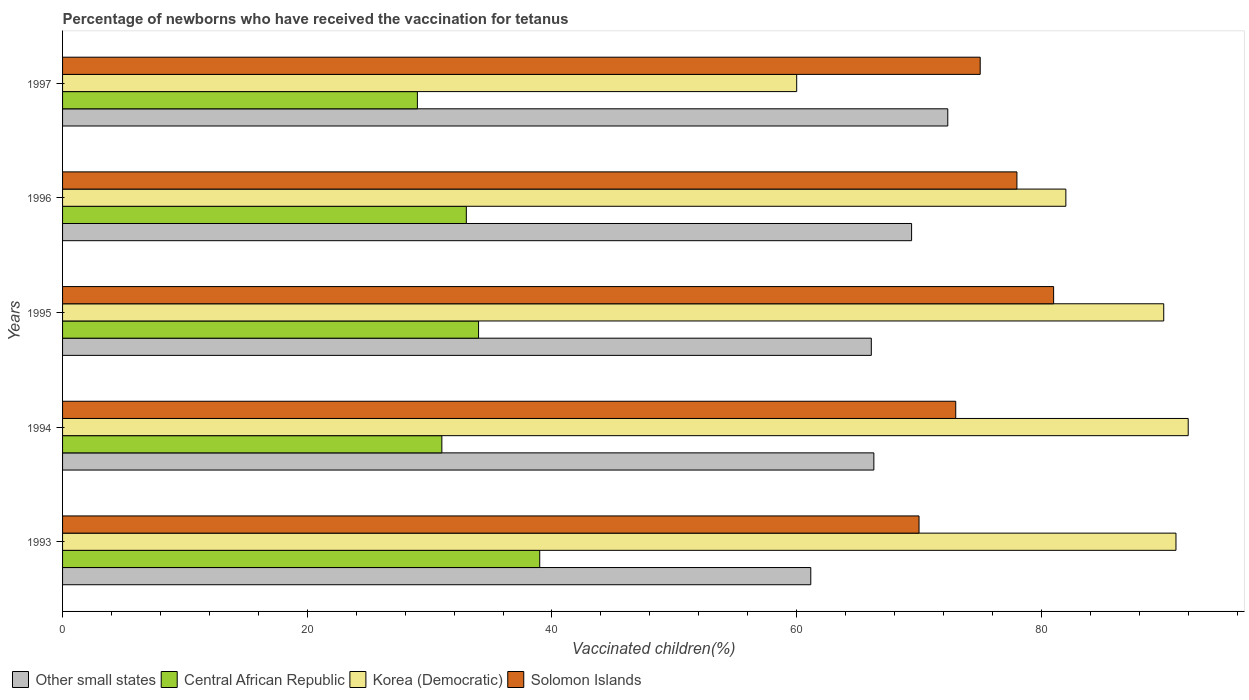How many groups of bars are there?
Make the answer very short. 5. Are the number of bars per tick equal to the number of legend labels?
Your response must be concise. Yes. Are the number of bars on each tick of the Y-axis equal?
Provide a short and direct response. Yes. In how many cases, is the number of bars for a given year not equal to the number of legend labels?
Ensure brevity in your answer.  0. What is the percentage of vaccinated children in Other small states in 1993?
Your answer should be compact. 61.15. Across all years, what is the maximum percentage of vaccinated children in Korea (Democratic)?
Offer a terse response. 92. Across all years, what is the minimum percentage of vaccinated children in Other small states?
Provide a short and direct response. 61.15. In which year was the percentage of vaccinated children in Korea (Democratic) minimum?
Make the answer very short. 1997. What is the total percentage of vaccinated children in Solomon Islands in the graph?
Make the answer very short. 377. What is the difference between the percentage of vaccinated children in Other small states in 1994 and that in 1997?
Your answer should be compact. -6.04. What is the difference between the percentage of vaccinated children in Other small states in 1993 and the percentage of vaccinated children in Central African Republic in 1997?
Ensure brevity in your answer.  32.15. What is the average percentage of vaccinated children in Solomon Islands per year?
Offer a very short reply. 75.4. What is the ratio of the percentage of vaccinated children in Other small states in 1994 to that in 1995?
Give a very brief answer. 1. Is the difference between the percentage of vaccinated children in Korea (Democratic) in 1995 and 1996 greater than the difference between the percentage of vaccinated children in Solomon Islands in 1995 and 1996?
Give a very brief answer. Yes. What is the difference between the highest and the lowest percentage of vaccinated children in Solomon Islands?
Your response must be concise. 11. Is the sum of the percentage of vaccinated children in Korea (Democratic) in 1994 and 1996 greater than the maximum percentage of vaccinated children in Other small states across all years?
Keep it short and to the point. Yes. What does the 2nd bar from the top in 1993 represents?
Ensure brevity in your answer.  Korea (Democratic). What does the 3rd bar from the bottom in 1996 represents?
Your answer should be very brief. Korea (Democratic). Is it the case that in every year, the sum of the percentage of vaccinated children in Central African Republic and percentage of vaccinated children in Other small states is greater than the percentage of vaccinated children in Korea (Democratic)?
Give a very brief answer. Yes. How many bars are there?
Offer a very short reply. 20. Are all the bars in the graph horizontal?
Give a very brief answer. Yes. What is the difference between two consecutive major ticks on the X-axis?
Your response must be concise. 20. Does the graph contain any zero values?
Offer a very short reply. No. Where does the legend appear in the graph?
Provide a succinct answer. Bottom left. How many legend labels are there?
Keep it short and to the point. 4. What is the title of the graph?
Provide a succinct answer. Percentage of newborns who have received the vaccination for tetanus. Does "Antigua and Barbuda" appear as one of the legend labels in the graph?
Offer a very short reply. No. What is the label or title of the X-axis?
Offer a terse response. Vaccinated children(%). What is the Vaccinated children(%) in Other small states in 1993?
Provide a succinct answer. 61.15. What is the Vaccinated children(%) in Korea (Democratic) in 1993?
Offer a very short reply. 91. What is the Vaccinated children(%) of Other small states in 1994?
Keep it short and to the point. 66.31. What is the Vaccinated children(%) of Central African Republic in 1994?
Make the answer very short. 31. What is the Vaccinated children(%) in Korea (Democratic) in 1994?
Offer a very short reply. 92. What is the Vaccinated children(%) in Solomon Islands in 1994?
Provide a succinct answer. 73. What is the Vaccinated children(%) of Other small states in 1995?
Make the answer very short. 66.1. What is the Vaccinated children(%) in Korea (Democratic) in 1995?
Give a very brief answer. 90. What is the Vaccinated children(%) of Other small states in 1996?
Make the answer very short. 69.39. What is the Vaccinated children(%) in Central African Republic in 1996?
Offer a very short reply. 33. What is the Vaccinated children(%) in Other small states in 1997?
Your answer should be compact. 72.35. What is the Vaccinated children(%) in Central African Republic in 1997?
Provide a succinct answer. 29. Across all years, what is the maximum Vaccinated children(%) of Other small states?
Your answer should be very brief. 72.35. Across all years, what is the maximum Vaccinated children(%) in Central African Republic?
Offer a terse response. 39. Across all years, what is the maximum Vaccinated children(%) of Korea (Democratic)?
Keep it short and to the point. 92. Across all years, what is the minimum Vaccinated children(%) of Other small states?
Your answer should be very brief. 61.15. Across all years, what is the minimum Vaccinated children(%) of Solomon Islands?
Ensure brevity in your answer.  70. What is the total Vaccinated children(%) of Other small states in the graph?
Your response must be concise. 335.3. What is the total Vaccinated children(%) in Central African Republic in the graph?
Offer a very short reply. 166. What is the total Vaccinated children(%) of Korea (Democratic) in the graph?
Ensure brevity in your answer.  415. What is the total Vaccinated children(%) of Solomon Islands in the graph?
Keep it short and to the point. 377. What is the difference between the Vaccinated children(%) of Other small states in 1993 and that in 1994?
Your answer should be compact. -5.16. What is the difference between the Vaccinated children(%) in Central African Republic in 1993 and that in 1994?
Your response must be concise. 8. What is the difference between the Vaccinated children(%) in Solomon Islands in 1993 and that in 1994?
Keep it short and to the point. -3. What is the difference between the Vaccinated children(%) of Other small states in 1993 and that in 1995?
Provide a succinct answer. -4.95. What is the difference between the Vaccinated children(%) of Central African Republic in 1993 and that in 1995?
Provide a succinct answer. 5. What is the difference between the Vaccinated children(%) of Korea (Democratic) in 1993 and that in 1995?
Keep it short and to the point. 1. What is the difference between the Vaccinated children(%) in Other small states in 1993 and that in 1996?
Your answer should be compact. -8.24. What is the difference between the Vaccinated children(%) in Other small states in 1993 and that in 1997?
Provide a short and direct response. -11.2. What is the difference between the Vaccinated children(%) of Central African Republic in 1993 and that in 1997?
Offer a very short reply. 10. What is the difference between the Vaccinated children(%) of Korea (Democratic) in 1993 and that in 1997?
Offer a very short reply. 31. What is the difference between the Vaccinated children(%) in Solomon Islands in 1993 and that in 1997?
Provide a succinct answer. -5. What is the difference between the Vaccinated children(%) of Other small states in 1994 and that in 1995?
Provide a succinct answer. 0.21. What is the difference between the Vaccinated children(%) of Central African Republic in 1994 and that in 1995?
Provide a short and direct response. -3. What is the difference between the Vaccinated children(%) of Korea (Democratic) in 1994 and that in 1995?
Your answer should be very brief. 2. What is the difference between the Vaccinated children(%) of Other small states in 1994 and that in 1996?
Offer a very short reply. -3.08. What is the difference between the Vaccinated children(%) in Central African Republic in 1994 and that in 1996?
Offer a terse response. -2. What is the difference between the Vaccinated children(%) in Korea (Democratic) in 1994 and that in 1996?
Offer a very short reply. 10. What is the difference between the Vaccinated children(%) in Other small states in 1994 and that in 1997?
Your answer should be very brief. -6.04. What is the difference between the Vaccinated children(%) of Korea (Democratic) in 1994 and that in 1997?
Make the answer very short. 32. What is the difference between the Vaccinated children(%) in Other small states in 1995 and that in 1996?
Provide a succinct answer. -3.29. What is the difference between the Vaccinated children(%) of Central African Republic in 1995 and that in 1996?
Give a very brief answer. 1. What is the difference between the Vaccinated children(%) in Korea (Democratic) in 1995 and that in 1996?
Provide a short and direct response. 8. What is the difference between the Vaccinated children(%) in Solomon Islands in 1995 and that in 1996?
Provide a succinct answer. 3. What is the difference between the Vaccinated children(%) in Other small states in 1995 and that in 1997?
Your answer should be compact. -6.25. What is the difference between the Vaccinated children(%) in Central African Republic in 1995 and that in 1997?
Keep it short and to the point. 5. What is the difference between the Vaccinated children(%) in Korea (Democratic) in 1995 and that in 1997?
Your answer should be compact. 30. What is the difference between the Vaccinated children(%) in Other small states in 1996 and that in 1997?
Make the answer very short. -2.96. What is the difference between the Vaccinated children(%) in Central African Republic in 1996 and that in 1997?
Give a very brief answer. 4. What is the difference between the Vaccinated children(%) of Other small states in 1993 and the Vaccinated children(%) of Central African Republic in 1994?
Offer a terse response. 30.15. What is the difference between the Vaccinated children(%) of Other small states in 1993 and the Vaccinated children(%) of Korea (Democratic) in 1994?
Your answer should be very brief. -30.85. What is the difference between the Vaccinated children(%) of Other small states in 1993 and the Vaccinated children(%) of Solomon Islands in 1994?
Make the answer very short. -11.85. What is the difference between the Vaccinated children(%) in Central African Republic in 1993 and the Vaccinated children(%) in Korea (Democratic) in 1994?
Your answer should be compact. -53. What is the difference between the Vaccinated children(%) of Central African Republic in 1993 and the Vaccinated children(%) of Solomon Islands in 1994?
Provide a succinct answer. -34. What is the difference between the Vaccinated children(%) of Korea (Democratic) in 1993 and the Vaccinated children(%) of Solomon Islands in 1994?
Give a very brief answer. 18. What is the difference between the Vaccinated children(%) in Other small states in 1993 and the Vaccinated children(%) in Central African Republic in 1995?
Your answer should be compact. 27.15. What is the difference between the Vaccinated children(%) of Other small states in 1993 and the Vaccinated children(%) of Korea (Democratic) in 1995?
Your answer should be very brief. -28.85. What is the difference between the Vaccinated children(%) of Other small states in 1993 and the Vaccinated children(%) of Solomon Islands in 1995?
Offer a very short reply. -19.85. What is the difference between the Vaccinated children(%) in Central African Republic in 1993 and the Vaccinated children(%) in Korea (Democratic) in 1995?
Provide a short and direct response. -51. What is the difference between the Vaccinated children(%) of Central African Republic in 1993 and the Vaccinated children(%) of Solomon Islands in 1995?
Your answer should be very brief. -42. What is the difference between the Vaccinated children(%) of Other small states in 1993 and the Vaccinated children(%) of Central African Republic in 1996?
Offer a terse response. 28.15. What is the difference between the Vaccinated children(%) of Other small states in 1993 and the Vaccinated children(%) of Korea (Democratic) in 1996?
Provide a succinct answer. -20.85. What is the difference between the Vaccinated children(%) of Other small states in 1993 and the Vaccinated children(%) of Solomon Islands in 1996?
Your answer should be compact. -16.85. What is the difference between the Vaccinated children(%) in Central African Republic in 1993 and the Vaccinated children(%) in Korea (Democratic) in 1996?
Offer a terse response. -43. What is the difference between the Vaccinated children(%) in Central African Republic in 1993 and the Vaccinated children(%) in Solomon Islands in 1996?
Your answer should be compact. -39. What is the difference between the Vaccinated children(%) of Korea (Democratic) in 1993 and the Vaccinated children(%) of Solomon Islands in 1996?
Offer a very short reply. 13. What is the difference between the Vaccinated children(%) in Other small states in 1993 and the Vaccinated children(%) in Central African Republic in 1997?
Your answer should be compact. 32.15. What is the difference between the Vaccinated children(%) in Other small states in 1993 and the Vaccinated children(%) in Korea (Democratic) in 1997?
Your answer should be very brief. 1.15. What is the difference between the Vaccinated children(%) of Other small states in 1993 and the Vaccinated children(%) of Solomon Islands in 1997?
Your response must be concise. -13.85. What is the difference between the Vaccinated children(%) in Central African Republic in 1993 and the Vaccinated children(%) in Solomon Islands in 1997?
Provide a short and direct response. -36. What is the difference between the Vaccinated children(%) of Korea (Democratic) in 1993 and the Vaccinated children(%) of Solomon Islands in 1997?
Offer a terse response. 16. What is the difference between the Vaccinated children(%) in Other small states in 1994 and the Vaccinated children(%) in Central African Republic in 1995?
Ensure brevity in your answer.  32.31. What is the difference between the Vaccinated children(%) in Other small states in 1994 and the Vaccinated children(%) in Korea (Democratic) in 1995?
Make the answer very short. -23.69. What is the difference between the Vaccinated children(%) in Other small states in 1994 and the Vaccinated children(%) in Solomon Islands in 1995?
Your answer should be very brief. -14.69. What is the difference between the Vaccinated children(%) in Central African Republic in 1994 and the Vaccinated children(%) in Korea (Democratic) in 1995?
Keep it short and to the point. -59. What is the difference between the Vaccinated children(%) of Central African Republic in 1994 and the Vaccinated children(%) of Solomon Islands in 1995?
Give a very brief answer. -50. What is the difference between the Vaccinated children(%) of Other small states in 1994 and the Vaccinated children(%) of Central African Republic in 1996?
Your response must be concise. 33.31. What is the difference between the Vaccinated children(%) of Other small states in 1994 and the Vaccinated children(%) of Korea (Democratic) in 1996?
Your answer should be very brief. -15.69. What is the difference between the Vaccinated children(%) of Other small states in 1994 and the Vaccinated children(%) of Solomon Islands in 1996?
Your response must be concise. -11.69. What is the difference between the Vaccinated children(%) of Central African Republic in 1994 and the Vaccinated children(%) of Korea (Democratic) in 1996?
Offer a very short reply. -51. What is the difference between the Vaccinated children(%) of Central African Republic in 1994 and the Vaccinated children(%) of Solomon Islands in 1996?
Offer a very short reply. -47. What is the difference between the Vaccinated children(%) in Other small states in 1994 and the Vaccinated children(%) in Central African Republic in 1997?
Provide a short and direct response. 37.31. What is the difference between the Vaccinated children(%) in Other small states in 1994 and the Vaccinated children(%) in Korea (Democratic) in 1997?
Make the answer very short. 6.31. What is the difference between the Vaccinated children(%) of Other small states in 1994 and the Vaccinated children(%) of Solomon Islands in 1997?
Provide a succinct answer. -8.69. What is the difference between the Vaccinated children(%) of Central African Republic in 1994 and the Vaccinated children(%) of Solomon Islands in 1997?
Give a very brief answer. -44. What is the difference between the Vaccinated children(%) in Korea (Democratic) in 1994 and the Vaccinated children(%) in Solomon Islands in 1997?
Make the answer very short. 17. What is the difference between the Vaccinated children(%) of Other small states in 1995 and the Vaccinated children(%) of Central African Republic in 1996?
Provide a succinct answer. 33.1. What is the difference between the Vaccinated children(%) in Other small states in 1995 and the Vaccinated children(%) in Korea (Democratic) in 1996?
Your response must be concise. -15.9. What is the difference between the Vaccinated children(%) of Other small states in 1995 and the Vaccinated children(%) of Solomon Islands in 1996?
Give a very brief answer. -11.9. What is the difference between the Vaccinated children(%) in Central African Republic in 1995 and the Vaccinated children(%) in Korea (Democratic) in 1996?
Ensure brevity in your answer.  -48. What is the difference between the Vaccinated children(%) in Central African Republic in 1995 and the Vaccinated children(%) in Solomon Islands in 1996?
Ensure brevity in your answer.  -44. What is the difference between the Vaccinated children(%) in Other small states in 1995 and the Vaccinated children(%) in Central African Republic in 1997?
Your answer should be compact. 37.1. What is the difference between the Vaccinated children(%) of Other small states in 1995 and the Vaccinated children(%) of Korea (Democratic) in 1997?
Provide a succinct answer. 6.1. What is the difference between the Vaccinated children(%) of Other small states in 1995 and the Vaccinated children(%) of Solomon Islands in 1997?
Your answer should be compact. -8.9. What is the difference between the Vaccinated children(%) in Central African Republic in 1995 and the Vaccinated children(%) in Solomon Islands in 1997?
Provide a succinct answer. -41. What is the difference between the Vaccinated children(%) in Other small states in 1996 and the Vaccinated children(%) in Central African Republic in 1997?
Make the answer very short. 40.39. What is the difference between the Vaccinated children(%) in Other small states in 1996 and the Vaccinated children(%) in Korea (Democratic) in 1997?
Offer a very short reply. 9.39. What is the difference between the Vaccinated children(%) in Other small states in 1996 and the Vaccinated children(%) in Solomon Islands in 1997?
Your answer should be compact. -5.61. What is the difference between the Vaccinated children(%) of Central African Republic in 1996 and the Vaccinated children(%) of Solomon Islands in 1997?
Make the answer very short. -42. What is the difference between the Vaccinated children(%) of Korea (Democratic) in 1996 and the Vaccinated children(%) of Solomon Islands in 1997?
Provide a short and direct response. 7. What is the average Vaccinated children(%) of Other small states per year?
Make the answer very short. 67.06. What is the average Vaccinated children(%) in Central African Republic per year?
Give a very brief answer. 33.2. What is the average Vaccinated children(%) in Korea (Democratic) per year?
Your answer should be very brief. 83. What is the average Vaccinated children(%) of Solomon Islands per year?
Offer a terse response. 75.4. In the year 1993, what is the difference between the Vaccinated children(%) in Other small states and Vaccinated children(%) in Central African Republic?
Make the answer very short. 22.15. In the year 1993, what is the difference between the Vaccinated children(%) in Other small states and Vaccinated children(%) in Korea (Democratic)?
Make the answer very short. -29.85. In the year 1993, what is the difference between the Vaccinated children(%) in Other small states and Vaccinated children(%) in Solomon Islands?
Ensure brevity in your answer.  -8.85. In the year 1993, what is the difference between the Vaccinated children(%) in Central African Republic and Vaccinated children(%) in Korea (Democratic)?
Provide a succinct answer. -52. In the year 1993, what is the difference between the Vaccinated children(%) of Central African Republic and Vaccinated children(%) of Solomon Islands?
Keep it short and to the point. -31. In the year 1994, what is the difference between the Vaccinated children(%) of Other small states and Vaccinated children(%) of Central African Republic?
Provide a succinct answer. 35.31. In the year 1994, what is the difference between the Vaccinated children(%) of Other small states and Vaccinated children(%) of Korea (Democratic)?
Ensure brevity in your answer.  -25.69. In the year 1994, what is the difference between the Vaccinated children(%) of Other small states and Vaccinated children(%) of Solomon Islands?
Provide a succinct answer. -6.69. In the year 1994, what is the difference between the Vaccinated children(%) in Central African Republic and Vaccinated children(%) in Korea (Democratic)?
Offer a terse response. -61. In the year 1994, what is the difference between the Vaccinated children(%) in Central African Republic and Vaccinated children(%) in Solomon Islands?
Your response must be concise. -42. In the year 1994, what is the difference between the Vaccinated children(%) of Korea (Democratic) and Vaccinated children(%) of Solomon Islands?
Provide a short and direct response. 19. In the year 1995, what is the difference between the Vaccinated children(%) of Other small states and Vaccinated children(%) of Central African Republic?
Your answer should be compact. 32.1. In the year 1995, what is the difference between the Vaccinated children(%) in Other small states and Vaccinated children(%) in Korea (Democratic)?
Provide a short and direct response. -23.9. In the year 1995, what is the difference between the Vaccinated children(%) of Other small states and Vaccinated children(%) of Solomon Islands?
Offer a terse response. -14.9. In the year 1995, what is the difference between the Vaccinated children(%) in Central African Republic and Vaccinated children(%) in Korea (Democratic)?
Offer a very short reply. -56. In the year 1995, what is the difference between the Vaccinated children(%) in Central African Republic and Vaccinated children(%) in Solomon Islands?
Give a very brief answer. -47. In the year 1996, what is the difference between the Vaccinated children(%) of Other small states and Vaccinated children(%) of Central African Republic?
Provide a succinct answer. 36.39. In the year 1996, what is the difference between the Vaccinated children(%) in Other small states and Vaccinated children(%) in Korea (Democratic)?
Offer a very short reply. -12.61. In the year 1996, what is the difference between the Vaccinated children(%) of Other small states and Vaccinated children(%) of Solomon Islands?
Offer a very short reply. -8.61. In the year 1996, what is the difference between the Vaccinated children(%) of Central African Republic and Vaccinated children(%) of Korea (Democratic)?
Your answer should be very brief. -49. In the year 1996, what is the difference between the Vaccinated children(%) in Central African Republic and Vaccinated children(%) in Solomon Islands?
Your answer should be compact. -45. In the year 1996, what is the difference between the Vaccinated children(%) of Korea (Democratic) and Vaccinated children(%) of Solomon Islands?
Provide a succinct answer. 4. In the year 1997, what is the difference between the Vaccinated children(%) in Other small states and Vaccinated children(%) in Central African Republic?
Your answer should be compact. 43.35. In the year 1997, what is the difference between the Vaccinated children(%) of Other small states and Vaccinated children(%) of Korea (Democratic)?
Your answer should be very brief. 12.35. In the year 1997, what is the difference between the Vaccinated children(%) of Other small states and Vaccinated children(%) of Solomon Islands?
Your answer should be very brief. -2.65. In the year 1997, what is the difference between the Vaccinated children(%) of Central African Republic and Vaccinated children(%) of Korea (Democratic)?
Keep it short and to the point. -31. In the year 1997, what is the difference between the Vaccinated children(%) in Central African Republic and Vaccinated children(%) in Solomon Islands?
Your response must be concise. -46. In the year 1997, what is the difference between the Vaccinated children(%) of Korea (Democratic) and Vaccinated children(%) of Solomon Islands?
Your answer should be compact. -15. What is the ratio of the Vaccinated children(%) in Other small states in 1993 to that in 1994?
Offer a terse response. 0.92. What is the ratio of the Vaccinated children(%) of Central African Republic in 1993 to that in 1994?
Give a very brief answer. 1.26. What is the ratio of the Vaccinated children(%) in Solomon Islands in 1993 to that in 1994?
Give a very brief answer. 0.96. What is the ratio of the Vaccinated children(%) of Other small states in 1993 to that in 1995?
Your response must be concise. 0.93. What is the ratio of the Vaccinated children(%) in Central African Republic in 1993 to that in 1995?
Give a very brief answer. 1.15. What is the ratio of the Vaccinated children(%) of Korea (Democratic) in 1993 to that in 1995?
Provide a succinct answer. 1.01. What is the ratio of the Vaccinated children(%) of Solomon Islands in 1993 to that in 1995?
Your response must be concise. 0.86. What is the ratio of the Vaccinated children(%) in Other small states in 1993 to that in 1996?
Provide a short and direct response. 0.88. What is the ratio of the Vaccinated children(%) of Central African Republic in 1993 to that in 1996?
Your answer should be very brief. 1.18. What is the ratio of the Vaccinated children(%) of Korea (Democratic) in 1993 to that in 1996?
Offer a terse response. 1.11. What is the ratio of the Vaccinated children(%) of Solomon Islands in 1993 to that in 1996?
Offer a very short reply. 0.9. What is the ratio of the Vaccinated children(%) of Other small states in 1993 to that in 1997?
Provide a short and direct response. 0.85. What is the ratio of the Vaccinated children(%) of Central African Republic in 1993 to that in 1997?
Ensure brevity in your answer.  1.34. What is the ratio of the Vaccinated children(%) in Korea (Democratic) in 1993 to that in 1997?
Offer a terse response. 1.52. What is the ratio of the Vaccinated children(%) of Solomon Islands in 1993 to that in 1997?
Your answer should be compact. 0.93. What is the ratio of the Vaccinated children(%) in Central African Republic in 1994 to that in 1995?
Provide a succinct answer. 0.91. What is the ratio of the Vaccinated children(%) of Korea (Democratic) in 1994 to that in 1995?
Offer a very short reply. 1.02. What is the ratio of the Vaccinated children(%) of Solomon Islands in 1994 to that in 1995?
Ensure brevity in your answer.  0.9. What is the ratio of the Vaccinated children(%) in Other small states in 1994 to that in 1996?
Offer a terse response. 0.96. What is the ratio of the Vaccinated children(%) in Central African Republic in 1994 to that in 1996?
Your answer should be compact. 0.94. What is the ratio of the Vaccinated children(%) in Korea (Democratic) in 1994 to that in 1996?
Provide a short and direct response. 1.12. What is the ratio of the Vaccinated children(%) of Solomon Islands in 1994 to that in 1996?
Your response must be concise. 0.94. What is the ratio of the Vaccinated children(%) in Other small states in 1994 to that in 1997?
Offer a very short reply. 0.92. What is the ratio of the Vaccinated children(%) in Central African Republic in 1994 to that in 1997?
Your answer should be compact. 1.07. What is the ratio of the Vaccinated children(%) of Korea (Democratic) in 1994 to that in 1997?
Give a very brief answer. 1.53. What is the ratio of the Vaccinated children(%) in Solomon Islands in 1994 to that in 1997?
Offer a very short reply. 0.97. What is the ratio of the Vaccinated children(%) of Other small states in 1995 to that in 1996?
Offer a very short reply. 0.95. What is the ratio of the Vaccinated children(%) of Central African Republic in 1995 to that in 1996?
Offer a very short reply. 1.03. What is the ratio of the Vaccinated children(%) of Korea (Democratic) in 1995 to that in 1996?
Ensure brevity in your answer.  1.1. What is the ratio of the Vaccinated children(%) in Other small states in 1995 to that in 1997?
Provide a short and direct response. 0.91. What is the ratio of the Vaccinated children(%) in Central African Republic in 1995 to that in 1997?
Your response must be concise. 1.17. What is the ratio of the Vaccinated children(%) of Solomon Islands in 1995 to that in 1997?
Make the answer very short. 1.08. What is the ratio of the Vaccinated children(%) in Other small states in 1996 to that in 1997?
Your response must be concise. 0.96. What is the ratio of the Vaccinated children(%) in Central African Republic in 1996 to that in 1997?
Keep it short and to the point. 1.14. What is the ratio of the Vaccinated children(%) of Korea (Democratic) in 1996 to that in 1997?
Offer a very short reply. 1.37. What is the difference between the highest and the second highest Vaccinated children(%) of Other small states?
Make the answer very short. 2.96. What is the difference between the highest and the lowest Vaccinated children(%) of Other small states?
Offer a terse response. 11.2. What is the difference between the highest and the lowest Vaccinated children(%) of Korea (Democratic)?
Make the answer very short. 32. 